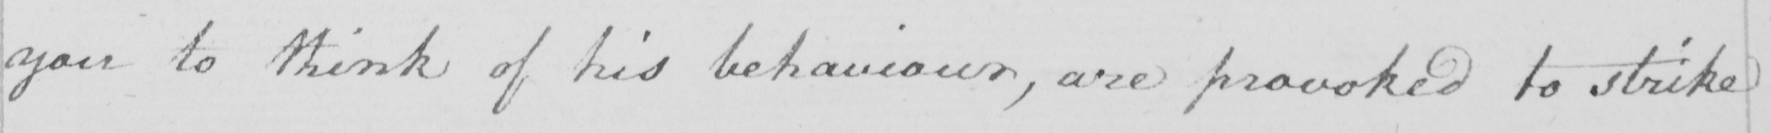What does this handwritten line say? you to think of his behaviour, are provoked to strike 